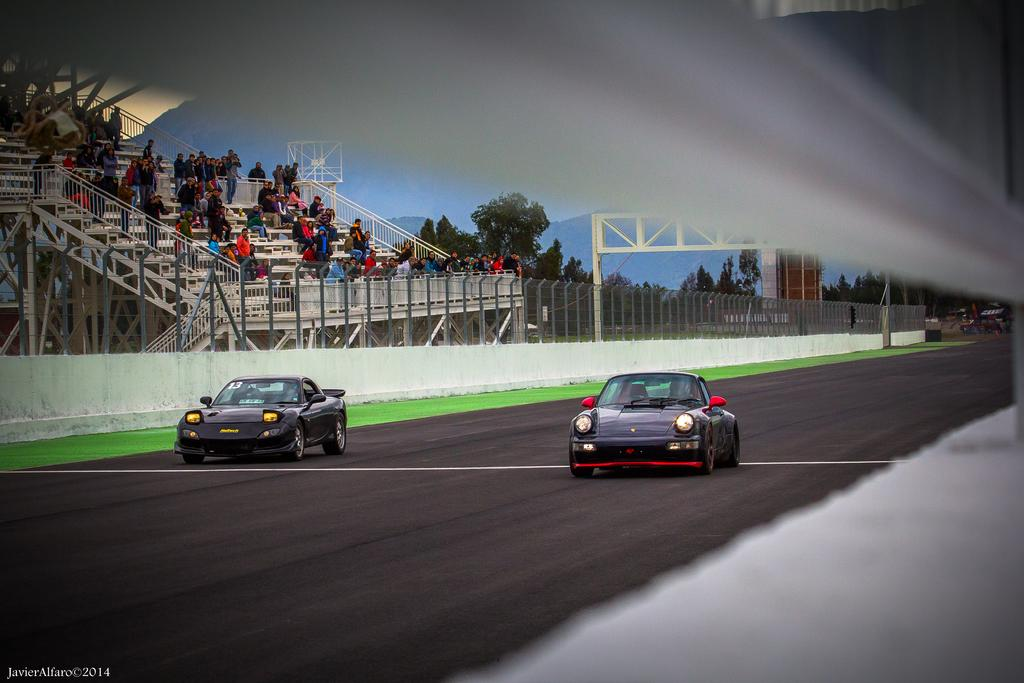What can be seen on the road in the image? There are vehicles on the road in the image. What else is visible in the background of the image? There are people and trees present in the background of the image. What type of natural landform can be seen in the background of the image? Mountains are visible in the background of the image. What letter is being held by the robin in the image? There is no robin or letter present in the image. 